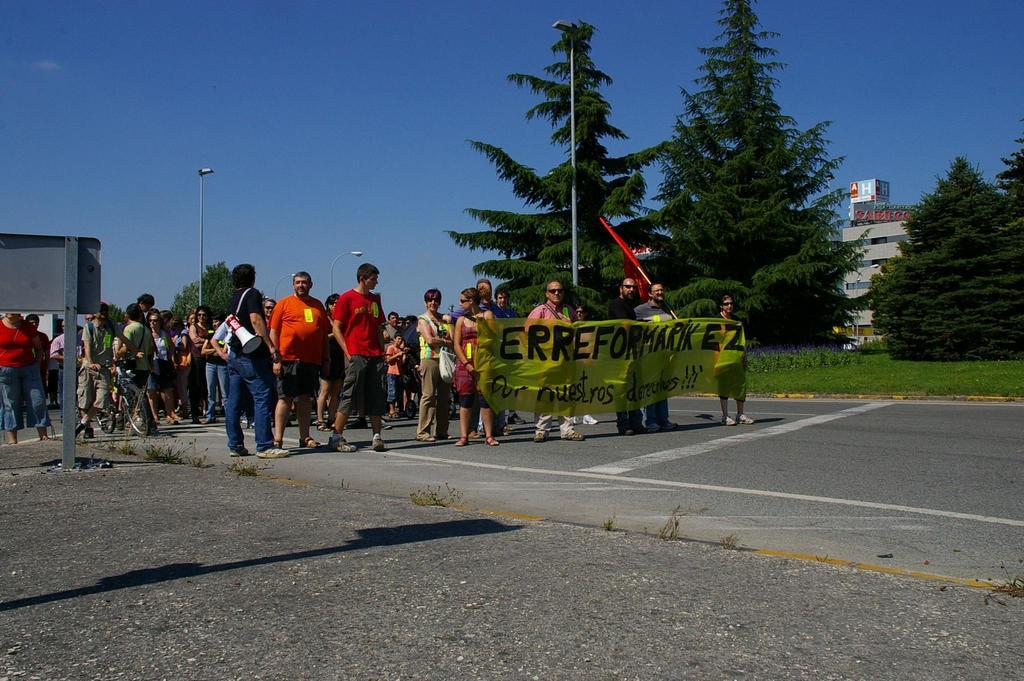<image>
Summarize the visual content of the image. People are marching behind a banner that says, 'Erreformarik EZ'. 